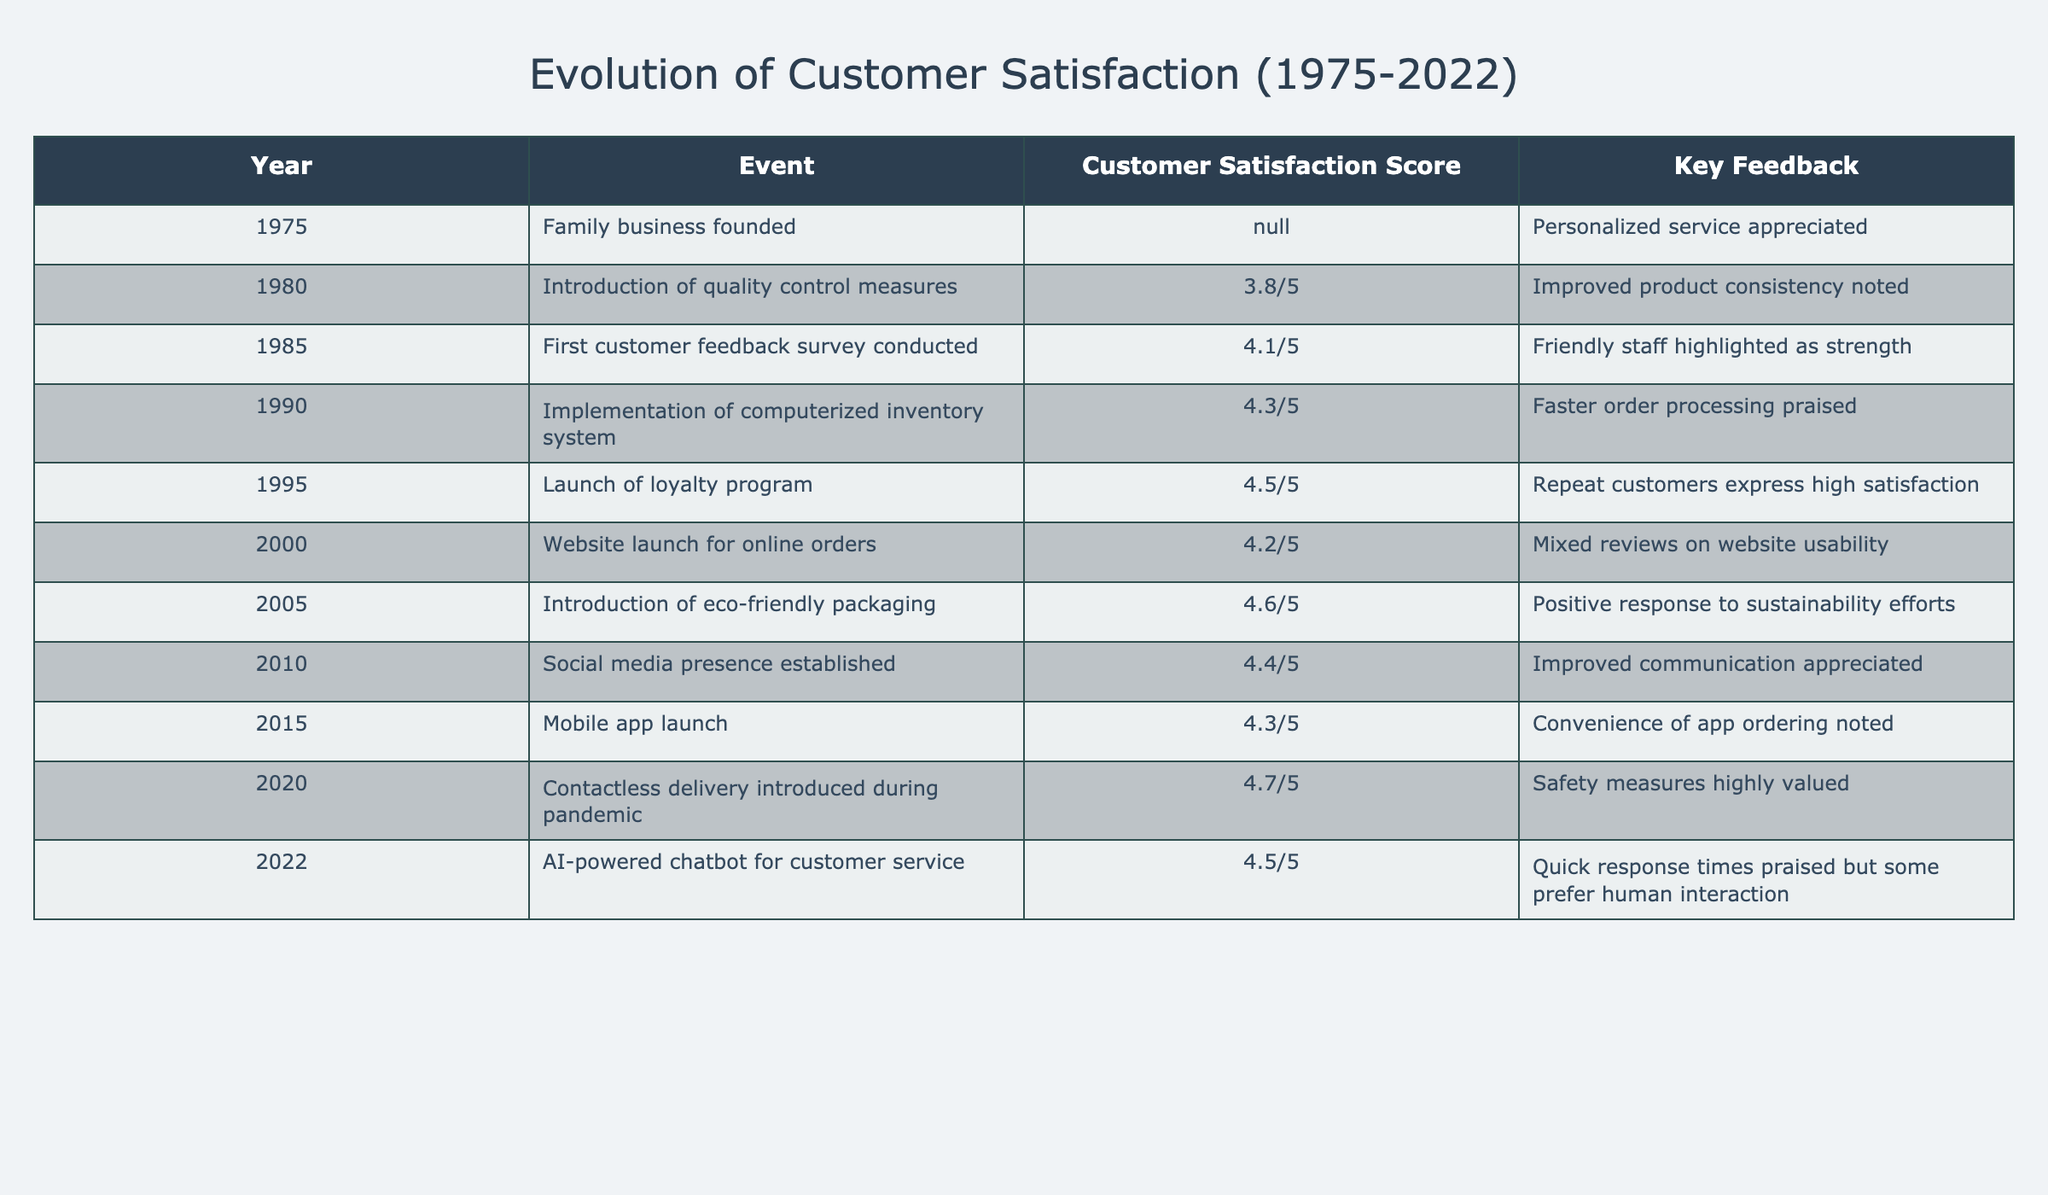What was the customer satisfaction score in 2000? The score in 2000 is explicitly listed in the table under the relevant year and column. It states that the customer satisfaction score was 4.2/5.
Answer: 4.2/5 Which event in 2010 resulted in a customer satisfaction score of 4.4/5? Referring to the table, the event associated with the score of 4.4/5 in 2010 is the establishment of a social media presence.
Answer: Social media presence established What was the highest recorded customer satisfaction score in the table? To determine the highest score, I compare all the satisfaction scores listed. The maximum is 4.7/5, which occurred in 2020.
Answer: 4.7/5 What was the difference in customer satisfaction scores between 1995 and 2022? First, identify the scores: in 1995 it was 4.5/5 and in 2022 it was 4.5/5. The difference is calculated as 4.5 - 4.5 = 0.
Answer: 0 Was there any year in which the customer satisfaction score decreased compared to the previous year? By examining the scores in the table year by year, we see there was no decrease compared to the previous year; all transitions show either increases or stability.
Answer: No What is the average customer satisfaction score from 1975 to 2022? First, I sum the scores: (3.8 + 4.1 + 4.3 + 4.5 + 4.2 + 4.6 + 4.4 + 4.3 + 4.7 + 4.5) = 44.5. Dividing by the number of entries: 44.5 / 10 = 4.45.
Answer: 4.45 Which key feedback statement was recorded in 2005? The table indicates that in 2005, the key feedback was a positive response to the eco-friendly packaging.
Answer: Positive response to sustainability efforts How many events received a score of 4.5 or higher? I count the events with scores of 4.5 or higher: 1995, 2005, 2020, and 2022 which totals to 4 events.
Answer: 4 